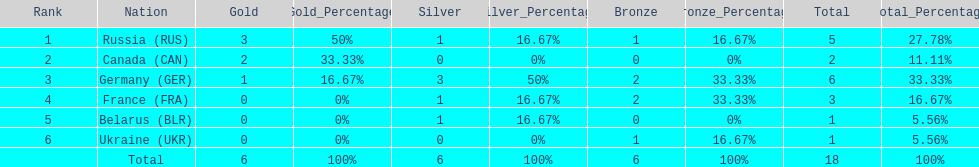I'm looking to parse the entire table for insights. Could you assist me with that? {'header': ['Rank', 'Nation', 'Gold', 'Gold_Percentage', 'Silver', 'Silver_Percentage', 'Bronze', 'Bronze_Percentage', 'Total', 'Total_Percentage'], 'rows': [['1', 'Russia\xa0(RUS)', '3', '50%', '1', '16.67%', '1', '16.67%', '5', '27.78%'], ['2', 'Canada\xa0(CAN)', '2', '33.33%', '0', '0%', '0', '0%', '2', '11.11%'], ['3', 'Germany\xa0(GER)', '1', '16.67%', '3', '50%', '2', '33.33%', '6', '33.33%'], ['4', 'France\xa0(FRA)', '0', '0%', '1', '16.67%', '2', '33.33%', '3', '16.67%'], ['5', 'Belarus\xa0(BLR)', '0', '0%', '1', '16.67%', '0', '0%', '1', '5.56%'], ['6', 'Ukraine\xa0(UKR)', '0', '0%', '0', '0%', '1', '16.67%', '1', '5.56%'], ['', 'Total', '6', '100%', '6', '100%', '6', '100%', '18', '100%']]} Who had a larger total medal count, france or canada? France. 